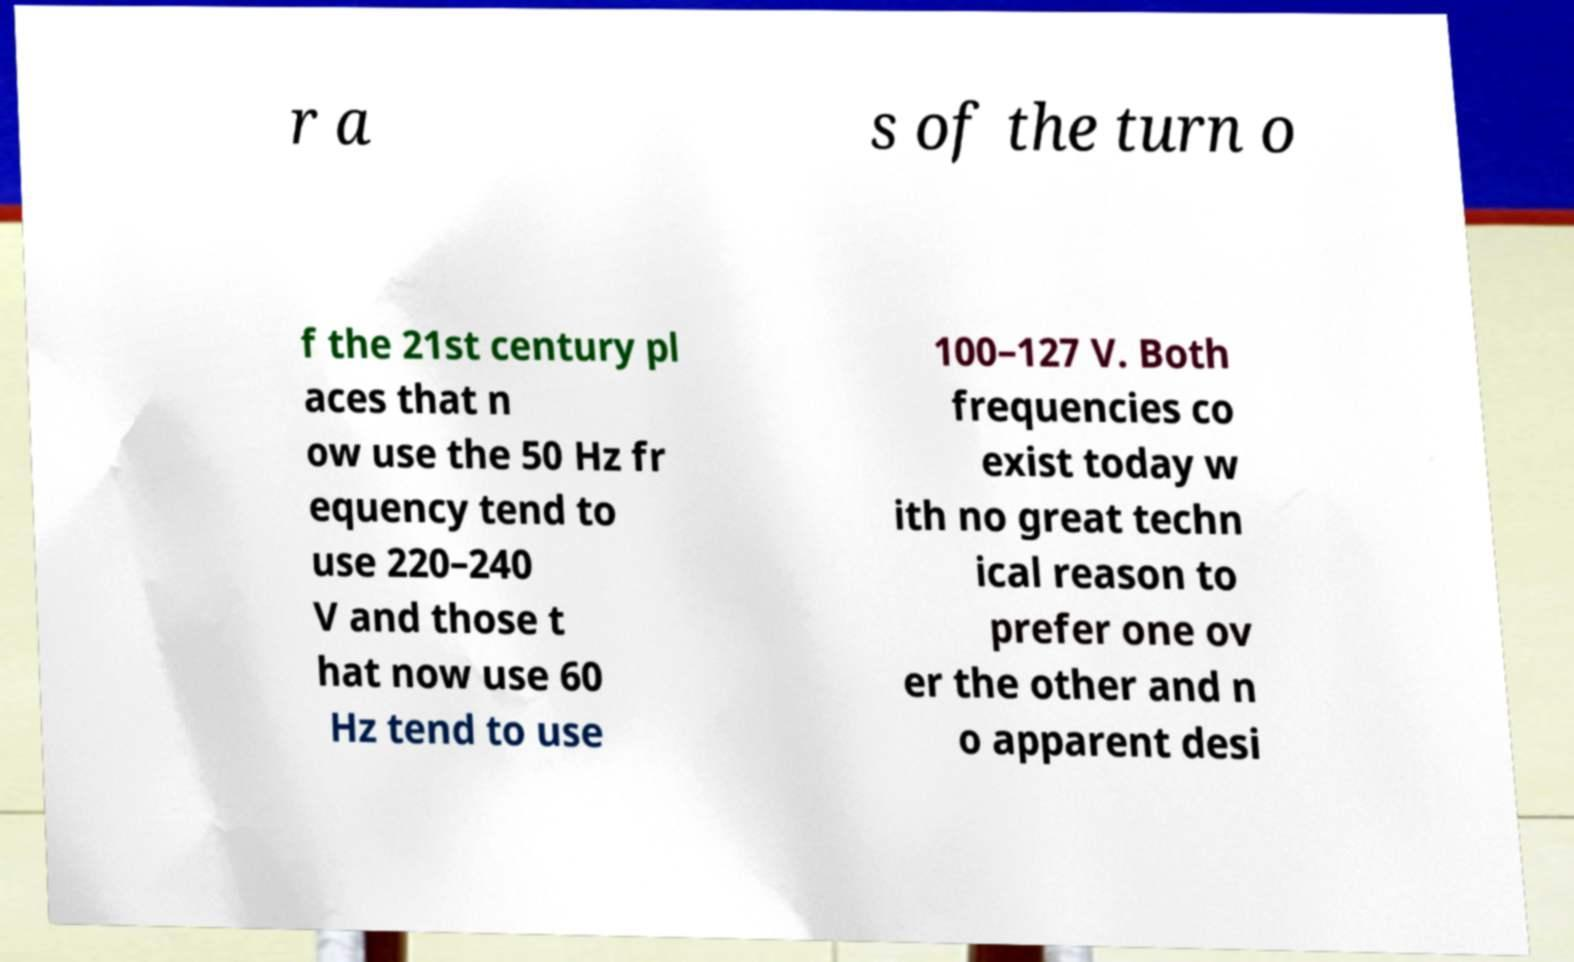Please identify and transcribe the text found in this image. r a s of the turn o f the 21st century pl aces that n ow use the 50 Hz fr equency tend to use 220–240 V and those t hat now use 60 Hz tend to use 100–127 V. Both frequencies co exist today w ith no great techn ical reason to prefer one ov er the other and n o apparent desi 